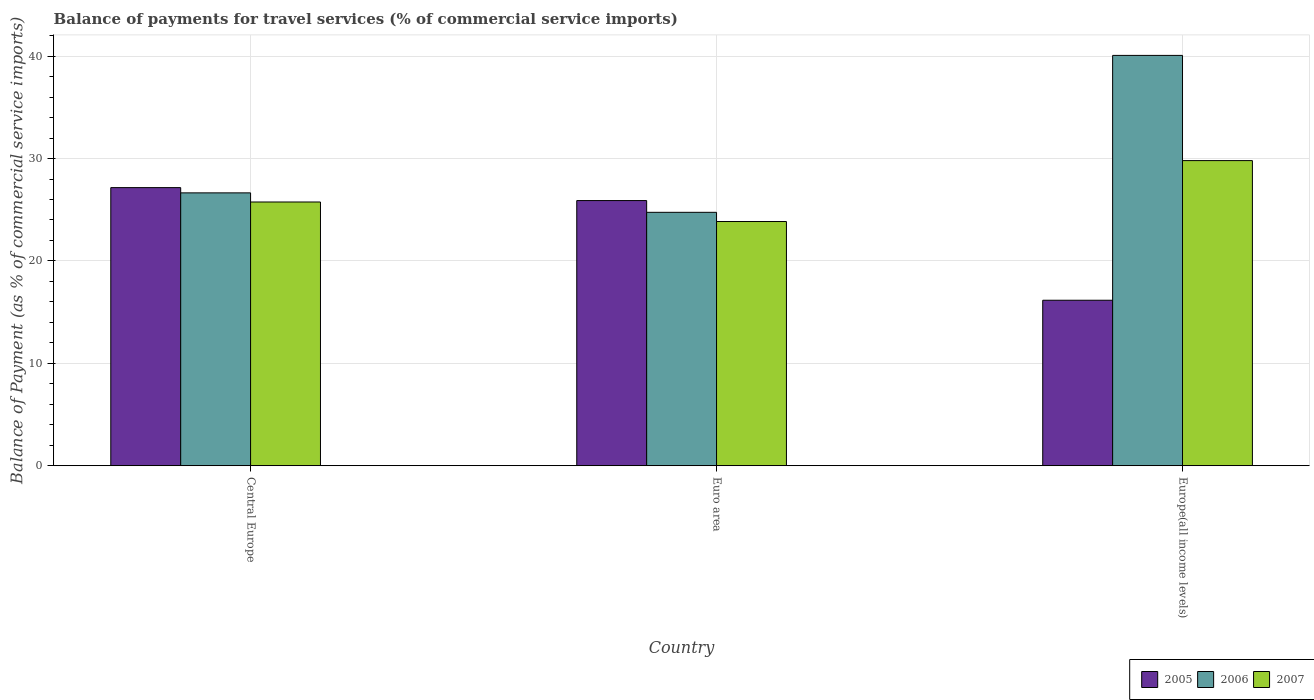How many different coloured bars are there?
Your response must be concise. 3. Are the number of bars on each tick of the X-axis equal?
Offer a terse response. Yes. What is the label of the 2nd group of bars from the left?
Keep it short and to the point. Euro area. In how many cases, is the number of bars for a given country not equal to the number of legend labels?
Offer a very short reply. 0. What is the balance of payments for travel services in 2007 in Central Europe?
Ensure brevity in your answer.  25.75. Across all countries, what is the maximum balance of payments for travel services in 2006?
Ensure brevity in your answer.  40.07. Across all countries, what is the minimum balance of payments for travel services in 2007?
Your answer should be very brief. 23.85. In which country was the balance of payments for travel services in 2007 maximum?
Keep it short and to the point. Europe(all income levels). In which country was the balance of payments for travel services in 2007 minimum?
Give a very brief answer. Euro area. What is the total balance of payments for travel services in 2007 in the graph?
Your answer should be very brief. 79.4. What is the difference between the balance of payments for travel services in 2006 in Central Europe and that in Europe(all income levels)?
Give a very brief answer. -13.43. What is the difference between the balance of payments for travel services in 2007 in Central Europe and the balance of payments for travel services in 2006 in Europe(all income levels)?
Keep it short and to the point. -14.32. What is the average balance of payments for travel services in 2006 per country?
Your answer should be compact. 30.49. What is the difference between the balance of payments for travel services of/in 2005 and balance of payments for travel services of/in 2006 in Europe(all income levels)?
Your response must be concise. -23.91. In how many countries, is the balance of payments for travel services in 2006 greater than 22 %?
Your answer should be very brief. 3. What is the ratio of the balance of payments for travel services in 2007 in Euro area to that in Europe(all income levels)?
Provide a short and direct response. 0.8. Is the balance of payments for travel services in 2006 in Central Europe less than that in Europe(all income levels)?
Your answer should be compact. Yes. What is the difference between the highest and the second highest balance of payments for travel services in 2006?
Your answer should be compact. 15.33. What is the difference between the highest and the lowest balance of payments for travel services in 2005?
Your answer should be very brief. 11. In how many countries, is the balance of payments for travel services in 2005 greater than the average balance of payments for travel services in 2005 taken over all countries?
Offer a terse response. 2. Is the sum of the balance of payments for travel services in 2007 in Central Europe and Euro area greater than the maximum balance of payments for travel services in 2006 across all countries?
Your answer should be very brief. Yes. What does the 2nd bar from the right in Euro area represents?
Your answer should be very brief. 2006. Is it the case that in every country, the sum of the balance of payments for travel services in 2007 and balance of payments for travel services in 2005 is greater than the balance of payments for travel services in 2006?
Your answer should be very brief. Yes. Are all the bars in the graph horizontal?
Provide a short and direct response. No. Are the values on the major ticks of Y-axis written in scientific E-notation?
Your response must be concise. No. Does the graph contain any zero values?
Provide a short and direct response. No. Does the graph contain grids?
Give a very brief answer. Yes. Where does the legend appear in the graph?
Provide a short and direct response. Bottom right. How are the legend labels stacked?
Keep it short and to the point. Horizontal. What is the title of the graph?
Give a very brief answer. Balance of payments for travel services (% of commercial service imports). What is the label or title of the X-axis?
Ensure brevity in your answer.  Country. What is the label or title of the Y-axis?
Offer a terse response. Balance of Payment (as % of commercial service imports). What is the Balance of Payment (as % of commercial service imports) of 2005 in Central Europe?
Offer a very short reply. 27.16. What is the Balance of Payment (as % of commercial service imports) of 2006 in Central Europe?
Ensure brevity in your answer.  26.65. What is the Balance of Payment (as % of commercial service imports) of 2007 in Central Europe?
Your response must be concise. 25.75. What is the Balance of Payment (as % of commercial service imports) in 2005 in Euro area?
Give a very brief answer. 25.89. What is the Balance of Payment (as % of commercial service imports) of 2006 in Euro area?
Offer a terse response. 24.75. What is the Balance of Payment (as % of commercial service imports) of 2007 in Euro area?
Offer a terse response. 23.85. What is the Balance of Payment (as % of commercial service imports) of 2005 in Europe(all income levels)?
Make the answer very short. 16.16. What is the Balance of Payment (as % of commercial service imports) of 2006 in Europe(all income levels)?
Offer a terse response. 40.07. What is the Balance of Payment (as % of commercial service imports) in 2007 in Europe(all income levels)?
Offer a terse response. 29.8. Across all countries, what is the maximum Balance of Payment (as % of commercial service imports) of 2005?
Provide a short and direct response. 27.16. Across all countries, what is the maximum Balance of Payment (as % of commercial service imports) in 2006?
Your answer should be very brief. 40.07. Across all countries, what is the maximum Balance of Payment (as % of commercial service imports) of 2007?
Give a very brief answer. 29.8. Across all countries, what is the minimum Balance of Payment (as % of commercial service imports) of 2005?
Offer a terse response. 16.16. Across all countries, what is the minimum Balance of Payment (as % of commercial service imports) of 2006?
Keep it short and to the point. 24.75. Across all countries, what is the minimum Balance of Payment (as % of commercial service imports) in 2007?
Keep it short and to the point. 23.85. What is the total Balance of Payment (as % of commercial service imports) of 2005 in the graph?
Provide a succinct answer. 69.21. What is the total Balance of Payment (as % of commercial service imports) in 2006 in the graph?
Your answer should be compact. 91.46. What is the total Balance of Payment (as % of commercial service imports) in 2007 in the graph?
Offer a terse response. 79.4. What is the difference between the Balance of Payment (as % of commercial service imports) in 2005 in Central Europe and that in Euro area?
Make the answer very short. 1.27. What is the difference between the Balance of Payment (as % of commercial service imports) of 2006 in Central Europe and that in Euro area?
Give a very brief answer. 1.9. What is the difference between the Balance of Payment (as % of commercial service imports) in 2007 in Central Europe and that in Euro area?
Make the answer very short. 1.91. What is the difference between the Balance of Payment (as % of commercial service imports) of 2005 in Central Europe and that in Europe(all income levels)?
Provide a succinct answer. 11. What is the difference between the Balance of Payment (as % of commercial service imports) in 2006 in Central Europe and that in Europe(all income levels)?
Your response must be concise. -13.43. What is the difference between the Balance of Payment (as % of commercial service imports) of 2007 in Central Europe and that in Europe(all income levels)?
Your response must be concise. -4.04. What is the difference between the Balance of Payment (as % of commercial service imports) in 2005 in Euro area and that in Europe(all income levels)?
Your answer should be compact. 9.73. What is the difference between the Balance of Payment (as % of commercial service imports) in 2006 in Euro area and that in Europe(all income levels)?
Offer a very short reply. -15.33. What is the difference between the Balance of Payment (as % of commercial service imports) in 2007 in Euro area and that in Europe(all income levels)?
Provide a short and direct response. -5.95. What is the difference between the Balance of Payment (as % of commercial service imports) of 2005 in Central Europe and the Balance of Payment (as % of commercial service imports) of 2006 in Euro area?
Offer a terse response. 2.41. What is the difference between the Balance of Payment (as % of commercial service imports) in 2005 in Central Europe and the Balance of Payment (as % of commercial service imports) in 2007 in Euro area?
Offer a very short reply. 3.31. What is the difference between the Balance of Payment (as % of commercial service imports) of 2006 in Central Europe and the Balance of Payment (as % of commercial service imports) of 2007 in Euro area?
Offer a terse response. 2.8. What is the difference between the Balance of Payment (as % of commercial service imports) of 2005 in Central Europe and the Balance of Payment (as % of commercial service imports) of 2006 in Europe(all income levels)?
Offer a very short reply. -12.91. What is the difference between the Balance of Payment (as % of commercial service imports) of 2005 in Central Europe and the Balance of Payment (as % of commercial service imports) of 2007 in Europe(all income levels)?
Offer a terse response. -2.64. What is the difference between the Balance of Payment (as % of commercial service imports) of 2006 in Central Europe and the Balance of Payment (as % of commercial service imports) of 2007 in Europe(all income levels)?
Your answer should be very brief. -3.15. What is the difference between the Balance of Payment (as % of commercial service imports) in 2005 in Euro area and the Balance of Payment (as % of commercial service imports) in 2006 in Europe(all income levels)?
Provide a succinct answer. -14.18. What is the difference between the Balance of Payment (as % of commercial service imports) of 2005 in Euro area and the Balance of Payment (as % of commercial service imports) of 2007 in Europe(all income levels)?
Provide a succinct answer. -3.9. What is the difference between the Balance of Payment (as % of commercial service imports) of 2006 in Euro area and the Balance of Payment (as % of commercial service imports) of 2007 in Europe(all income levels)?
Offer a terse response. -5.05. What is the average Balance of Payment (as % of commercial service imports) of 2005 per country?
Make the answer very short. 23.07. What is the average Balance of Payment (as % of commercial service imports) of 2006 per country?
Your response must be concise. 30.49. What is the average Balance of Payment (as % of commercial service imports) in 2007 per country?
Provide a succinct answer. 26.47. What is the difference between the Balance of Payment (as % of commercial service imports) in 2005 and Balance of Payment (as % of commercial service imports) in 2006 in Central Europe?
Your answer should be compact. 0.51. What is the difference between the Balance of Payment (as % of commercial service imports) of 2005 and Balance of Payment (as % of commercial service imports) of 2007 in Central Europe?
Offer a very short reply. 1.4. What is the difference between the Balance of Payment (as % of commercial service imports) in 2006 and Balance of Payment (as % of commercial service imports) in 2007 in Central Europe?
Your response must be concise. 0.89. What is the difference between the Balance of Payment (as % of commercial service imports) in 2005 and Balance of Payment (as % of commercial service imports) in 2006 in Euro area?
Your answer should be compact. 1.15. What is the difference between the Balance of Payment (as % of commercial service imports) of 2005 and Balance of Payment (as % of commercial service imports) of 2007 in Euro area?
Your response must be concise. 2.05. What is the difference between the Balance of Payment (as % of commercial service imports) of 2006 and Balance of Payment (as % of commercial service imports) of 2007 in Euro area?
Offer a very short reply. 0.9. What is the difference between the Balance of Payment (as % of commercial service imports) in 2005 and Balance of Payment (as % of commercial service imports) in 2006 in Europe(all income levels)?
Your answer should be compact. -23.91. What is the difference between the Balance of Payment (as % of commercial service imports) of 2005 and Balance of Payment (as % of commercial service imports) of 2007 in Europe(all income levels)?
Your answer should be compact. -13.64. What is the difference between the Balance of Payment (as % of commercial service imports) of 2006 and Balance of Payment (as % of commercial service imports) of 2007 in Europe(all income levels)?
Provide a succinct answer. 10.27. What is the ratio of the Balance of Payment (as % of commercial service imports) of 2005 in Central Europe to that in Euro area?
Give a very brief answer. 1.05. What is the ratio of the Balance of Payment (as % of commercial service imports) of 2006 in Central Europe to that in Euro area?
Make the answer very short. 1.08. What is the ratio of the Balance of Payment (as % of commercial service imports) in 2007 in Central Europe to that in Euro area?
Your response must be concise. 1.08. What is the ratio of the Balance of Payment (as % of commercial service imports) of 2005 in Central Europe to that in Europe(all income levels)?
Provide a succinct answer. 1.68. What is the ratio of the Balance of Payment (as % of commercial service imports) of 2006 in Central Europe to that in Europe(all income levels)?
Offer a terse response. 0.67. What is the ratio of the Balance of Payment (as % of commercial service imports) in 2007 in Central Europe to that in Europe(all income levels)?
Make the answer very short. 0.86. What is the ratio of the Balance of Payment (as % of commercial service imports) of 2005 in Euro area to that in Europe(all income levels)?
Ensure brevity in your answer.  1.6. What is the ratio of the Balance of Payment (as % of commercial service imports) of 2006 in Euro area to that in Europe(all income levels)?
Your answer should be compact. 0.62. What is the ratio of the Balance of Payment (as % of commercial service imports) in 2007 in Euro area to that in Europe(all income levels)?
Provide a succinct answer. 0.8. What is the difference between the highest and the second highest Balance of Payment (as % of commercial service imports) in 2005?
Give a very brief answer. 1.27. What is the difference between the highest and the second highest Balance of Payment (as % of commercial service imports) in 2006?
Provide a succinct answer. 13.43. What is the difference between the highest and the second highest Balance of Payment (as % of commercial service imports) of 2007?
Offer a terse response. 4.04. What is the difference between the highest and the lowest Balance of Payment (as % of commercial service imports) of 2005?
Your answer should be very brief. 11. What is the difference between the highest and the lowest Balance of Payment (as % of commercial service imports) in 2006?
Provide a short and direct response. 15.33. What is the difference between the highest and the lowest Balance of Payment (as % of commercial service imports) of 2007?
Your answer should be compact. 5.95. 